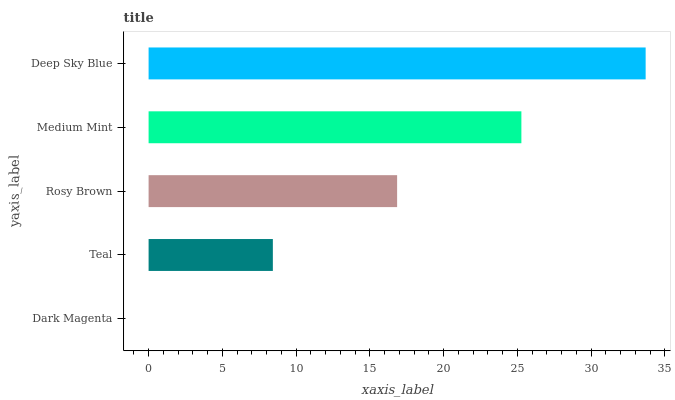Is Dark Magenta the minimum?
Answer yes or no. Yes. Is Deep Sky Blue the maximum?
Answer yes or no. Yes. Is Teal the minimum?
Answer yes or no. No. Is Teal the maximum?
Answer yes or no. No. Is Teal greater than Dark Magenta?
Answer yes or no. Yes. Is Dark Magenta less than Teal?
Answer yes or no. Yes. Is Dark Magenta greater than Teal?
Answer yes or no. No. Is Teal less than Dark Magenta?
Answer yes or no. No. Is Rosy Brown the high median?
Answer yes or no. Yes. Is Rosy Brown the low median?
Answer yes or no. Yes. Is Deep Sky Blue the high median?
Answer yes or no. No. Is Deep Sky Blue the low median?
Answer yes or no. No. 